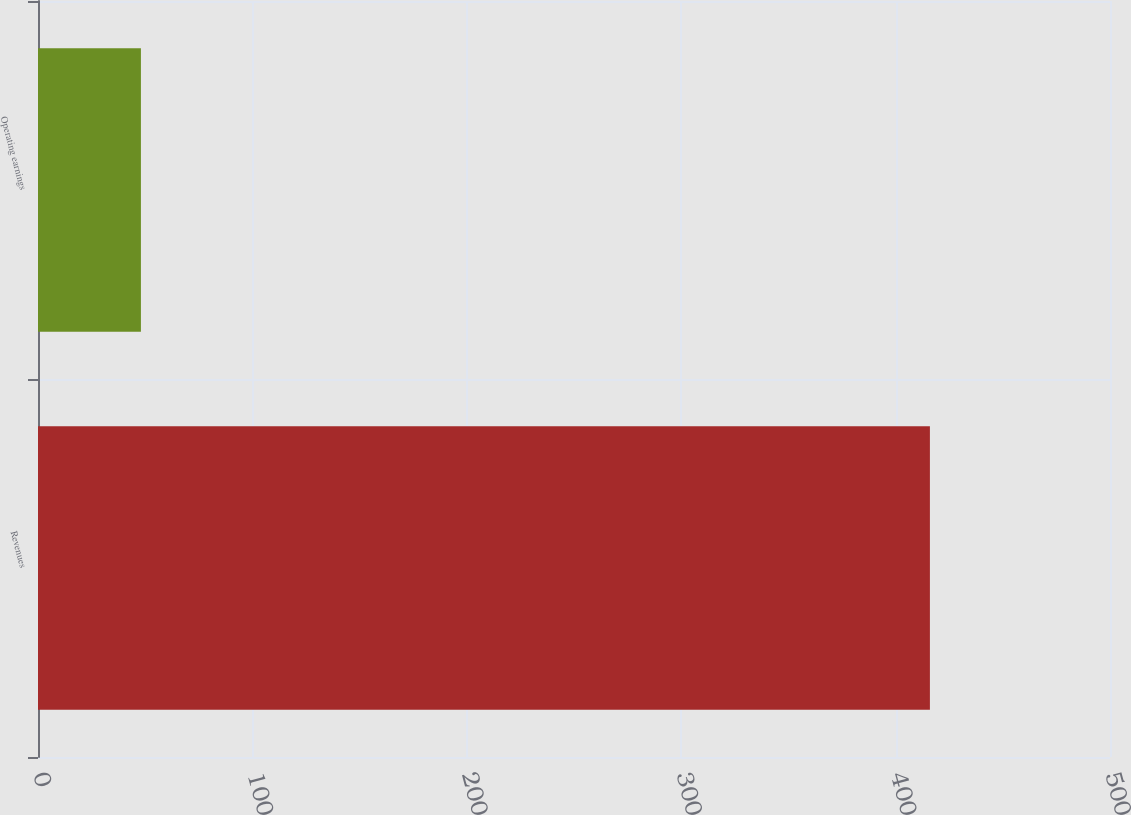Convert chart to OTSL. <chart><loc_0><loc_0><loc_500><loc_500><bar_chart><fcel>Revenues<fcel>Operating earnings<nl><fcel>416<fcel>48<nl></chart> 